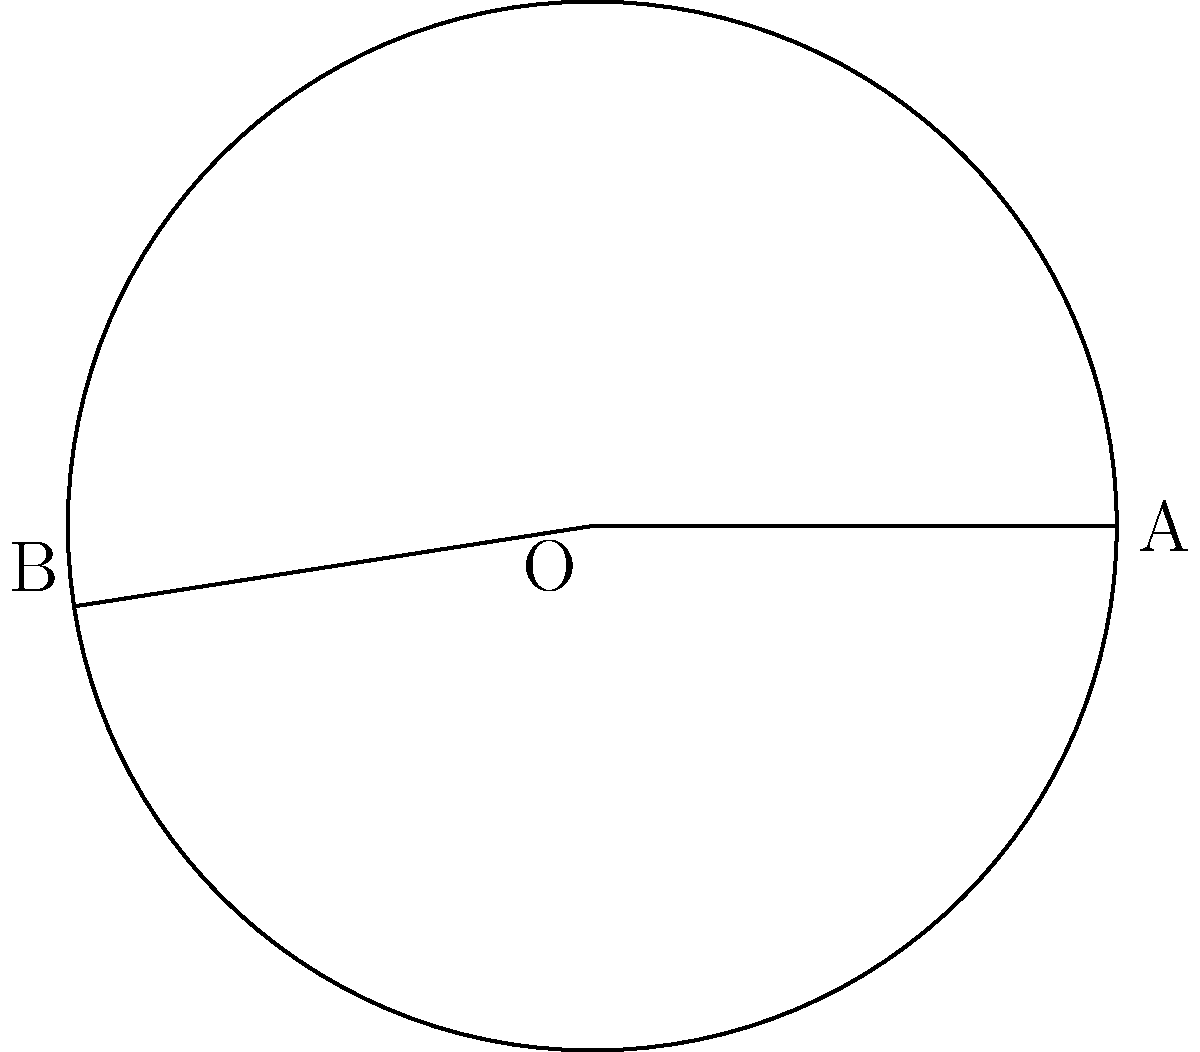At the therapeutic riding center, you're designing a curved trail path for your riders. The path forms an arc of a circle with radius 30 meters. If the central angle of the arc is 60°, what is the length of the curved trail path? Round your answer to the nearest meter. To solve this problem, we'll use the arc length formula:

$$ s = r\theta $$

Where:
$s$ = arc length
$r$ = radius of the circle
$\theta$ = central angle in radians

Step 1: Convert the central angle from degrees to radians.
$$ \theta = 60° \times \frac{\pi}{180°} = \frac{\pi}{3} \text{ radians} $$

Step 2: Apply the arc length formula.
$$ s = r\theta = 30 \times \frac{\pi}{3} = 10\pi \text{ meters} $$

Step 3: Calculate the result and round to the nearest meter.
$$ 10\pi \approx 31.4159... \text{ meters} $$
Rounded to the nearest meter: 31 meters.

This curved trail path of 31 meters provides an ideal length for therapeutic riding sessions, allowing riders to experience the benefits of horseback riding while navigating a gentle curve.
Answer: 31 meters 